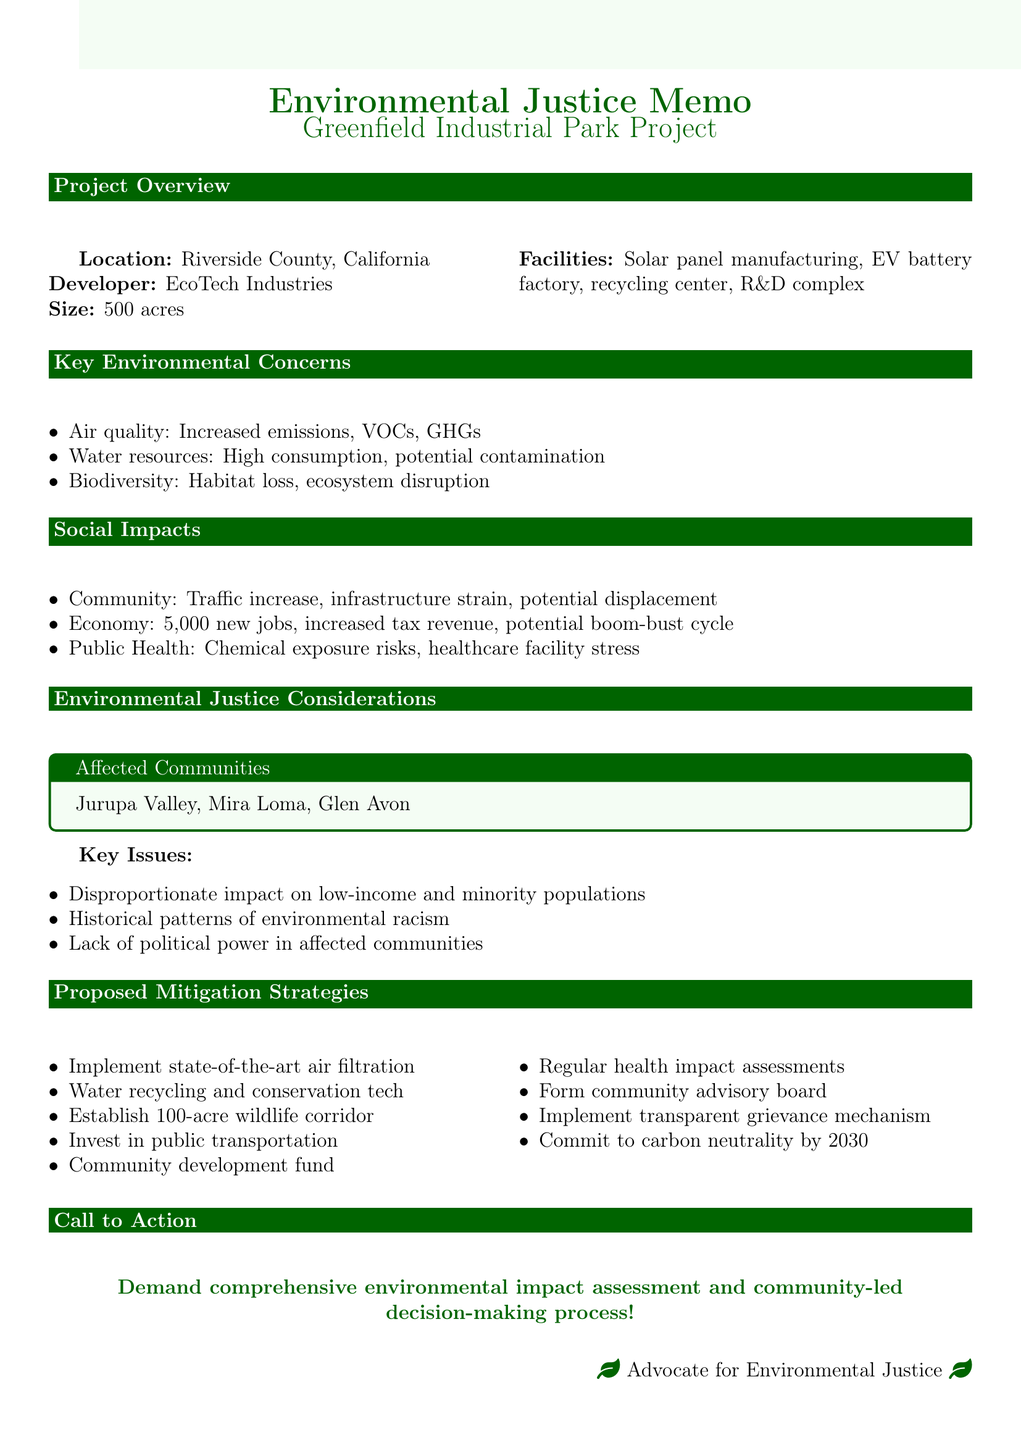What is the name of the project? The project's name is clearly stated in the document's title as "Greenfield Industrial Park".
Answer: Greenfield Industrial Park Who is the developer of the project? The developer's name is mentioned in the project overview.
Answer: EcoTech Industries How many acres does the project cover? The size of the project is indicated in the project overview.
Answer: 500 acres What is one of the main concerns regarding water resources? The document lists multiple concerns under water resources, one of which highlights the water consumption issue.
Answer: Increased water consumption in a drought-prone area What is a proposed action to address environmental justice? The document suggests a specific proposal under environmental justice considerations.
Answer: Formation of a community advisory board with decision-making power How many new jobs are expected to be created? The document states the expected number of new jobs in the economy section.
Answer: 5,000 new jobs What will the commitment to carbon neutrality aim for by? The timeline for carbon neutrality commitment is mentioned in the proposed mitigation strategies.
Answer: 2030 What ecological concern is highlighted regarding biodiversity? The concerns listed under biodiversity indicate significant ecological issues, including habitat loss.
Answer: Habitat loss for endangered species like the Stephens' kangaroo rat What mechanism is proposed for addressing community grievances? A specific strategy for community engagement and grievance resolution is described.
Answer: Implementation of a transparent grievance mechanism 